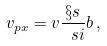<formula> <loc_0><loc_0><loc_500><loc_500>v _ { p x } = v \frac { \S s } { \ s i } b \, ,</formula> 